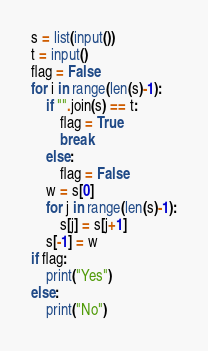Convert code to text. <code><loc_0><loc_0><loc_500><loc_500><_Python_>s = list(input())
t = input()
flag = False
for i in range(len(s)-1):
    if "".join(s) == t:
        flag = True
        break
    else:
        flag = False
    w = s[0]
    for j in range(len(s)-1):
        s[j] = s[j+1]
    s[-1] = w
if flag:
    print("Yes")
else:
    print("No")</code> 